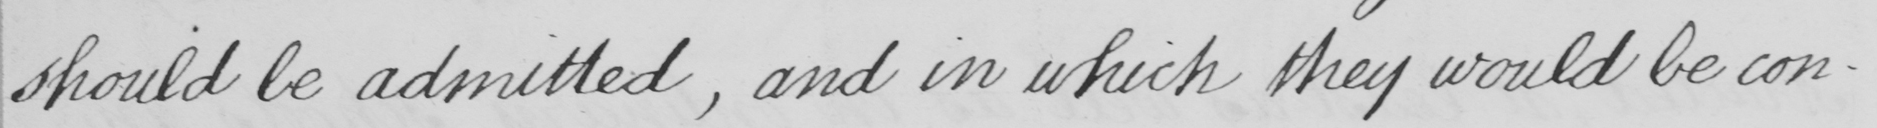Transcribe the text shown in this historical manuscript line. should be admitted , and in which they would be con- 